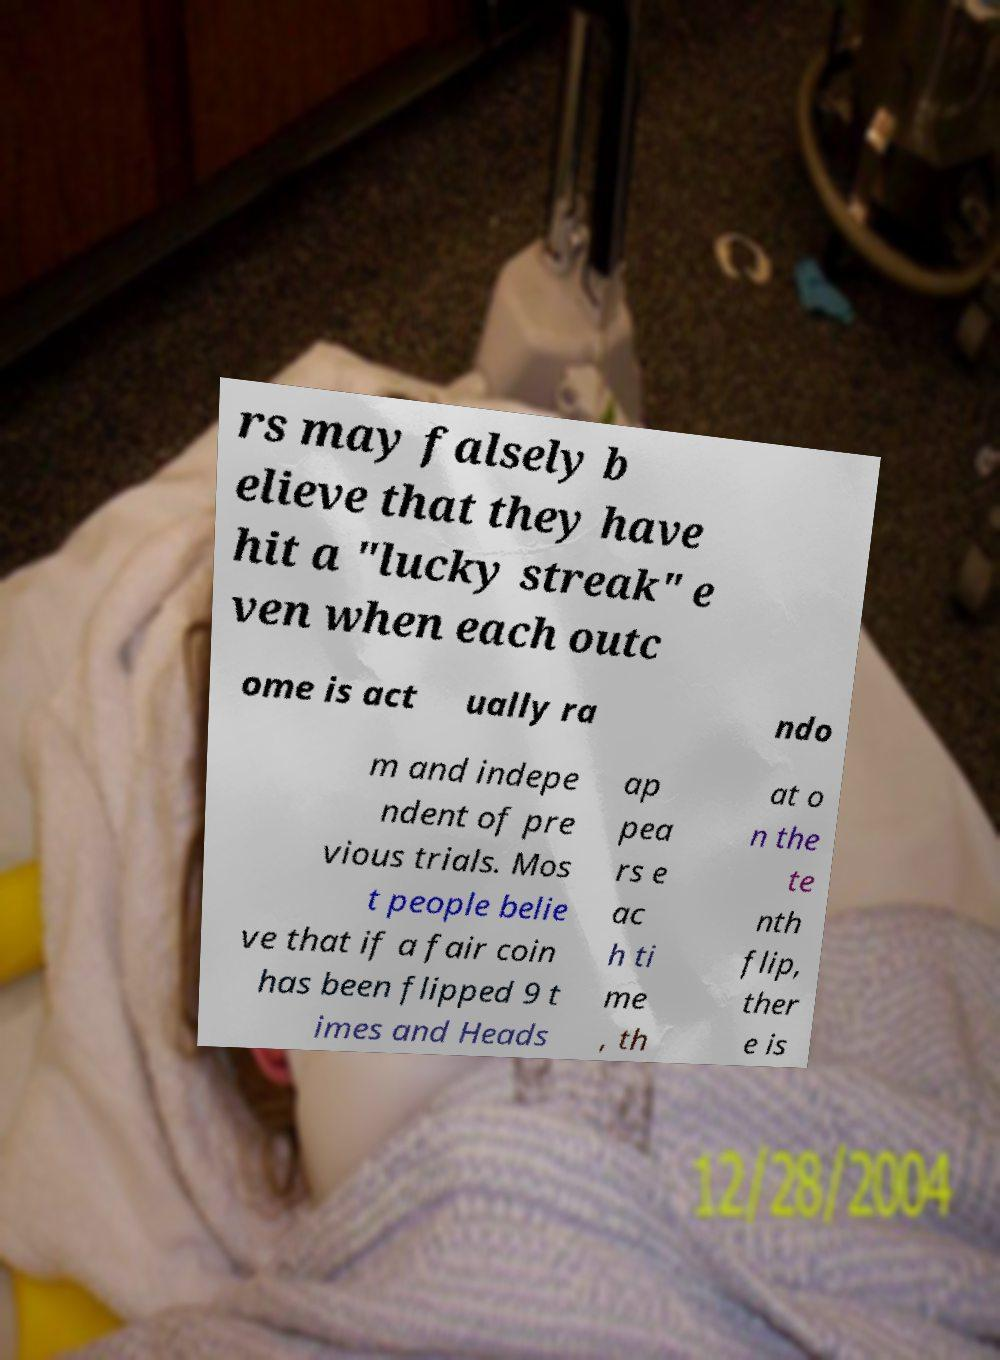Please read and relay the text visible in this image. What does it say? rs may falsely b elieve that they have hit a "lucky streak" e ven when each outc ome is act ually ra ndo m and indepe ndent of pre vious trials. Mos t people belie ve that if a fair coin has been flipped 9 t imes and Heads ap pea rs e ac h ti me , th at o n the te nth flip, ther e is 